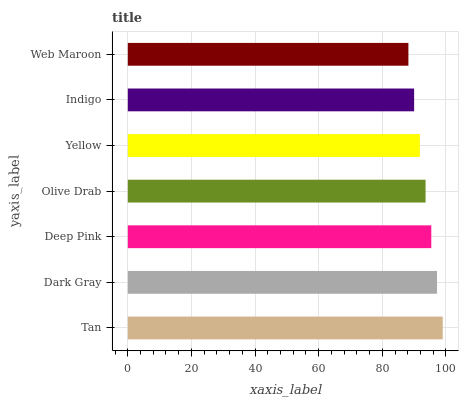Is Web Maroon the minimum?
Answer yes or no. Yes. Is Tan the maximum?
Answer yes or no. Yes. Is Dark Gray the minimum?
Answer yes or no. No. Is Dark Gray the maximum?
Answer yes or no. No. Is Tan greater than Dark Gray?
Answer yes or no. Yes. Is Dark Gray less than Tan?
Answer yes or no. Yes. Is Dark Gray greater than Tan?
Answer yes or no. No. Is Tan less than Dark Gray?
Answer yes or no. No. Is Olive Drab the high median?
Answer yes or no. Yes. Is Olive Drab the low median?
Answer yes or no. Yes. Is Tan the high median?
Answer yes or no. No. Is Indigo the low median?
Answer yes or no. No. 